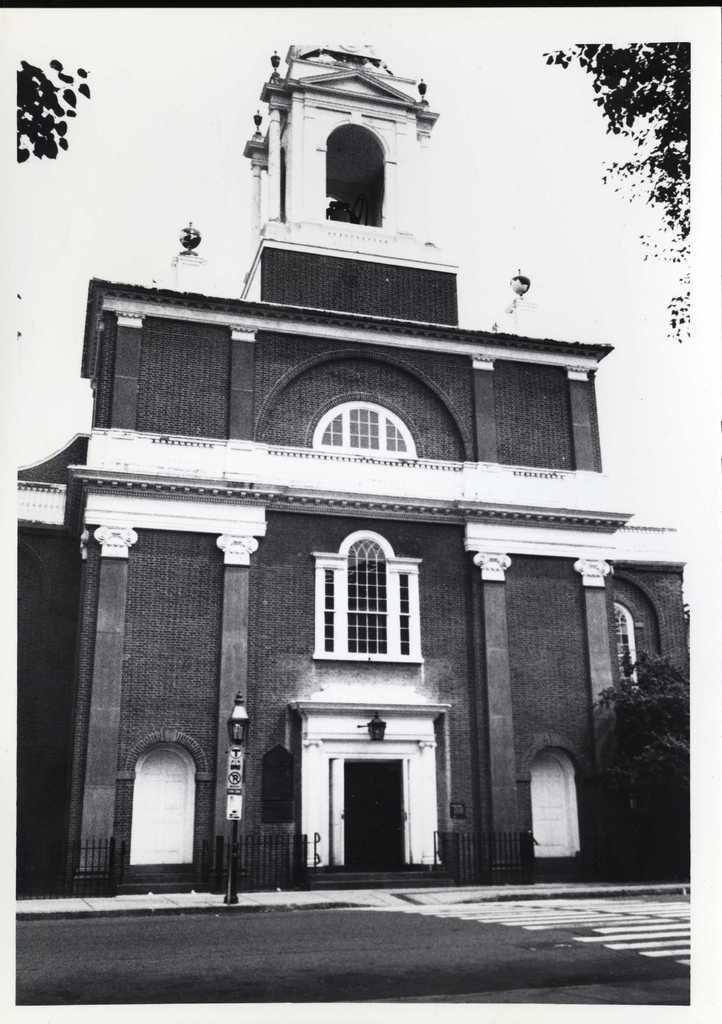What type of structure is in the image? There is a building in the image. What is in front of the building? There is a road in front of the building. What safety feature is present on the road? Zebra crossing lines are visible on the road. What type of vegetation is in the image? There is a tree in the image. What is visible at the top of the image? The sky is visible at the top of the image. What type of jelly can be seen hanging from the tree in the image? There is no jelly present in the image, and therefore no such activity can be observed. 